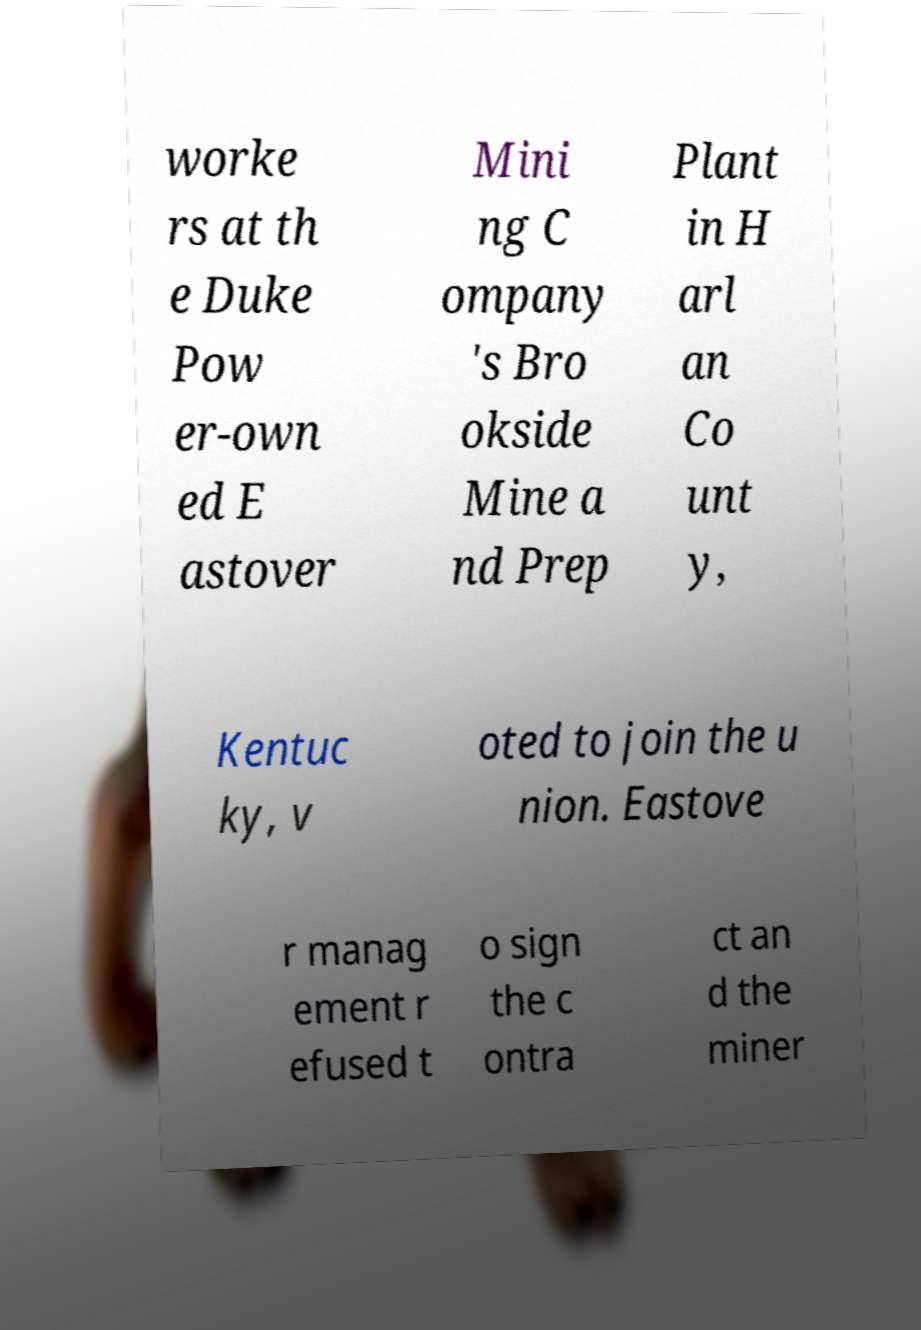For documentation purposes, I need the text within this image transcribed. Could you provide that? worke rs at th e Duke Pow er-own ed E astover Mini ng C ompany 's Bro okside Mine a nd Prep Plant in H arl an Co unt y, Kentuc ky, v oted to join the u nion. Eastove r manag ement r efused t o sign the c ontra ct an d the miner 